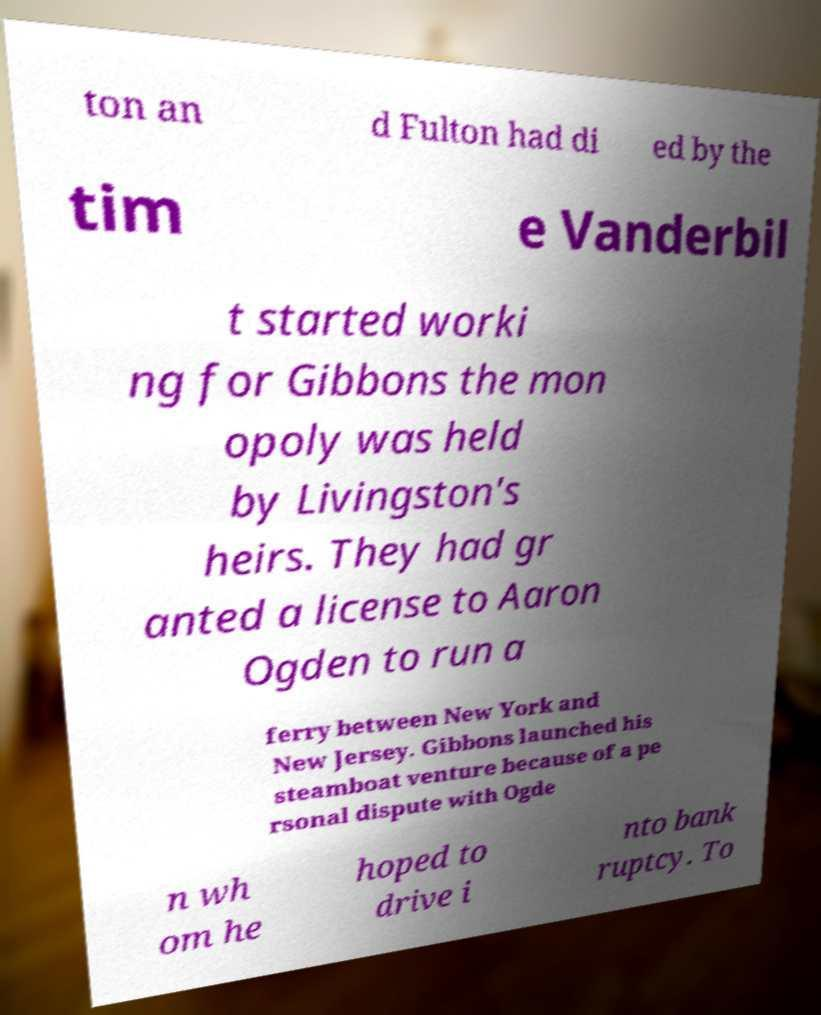There's text embedded in this image that I need extracted. Can you transcribe it verbatim? ton an d Fulton had di ed by the tim e Vanderbil t started worki ng for Gibbons the mon opoly was held by Livingston's heirs. They had gr anted a license to Aaron Ogden to run a ferry between New York and New Jersey. Gibbons launched his steamboat venture because of a pe rsonal dispute with Ogde n wh om he hoped to drive i nto bank ruptcy. To 